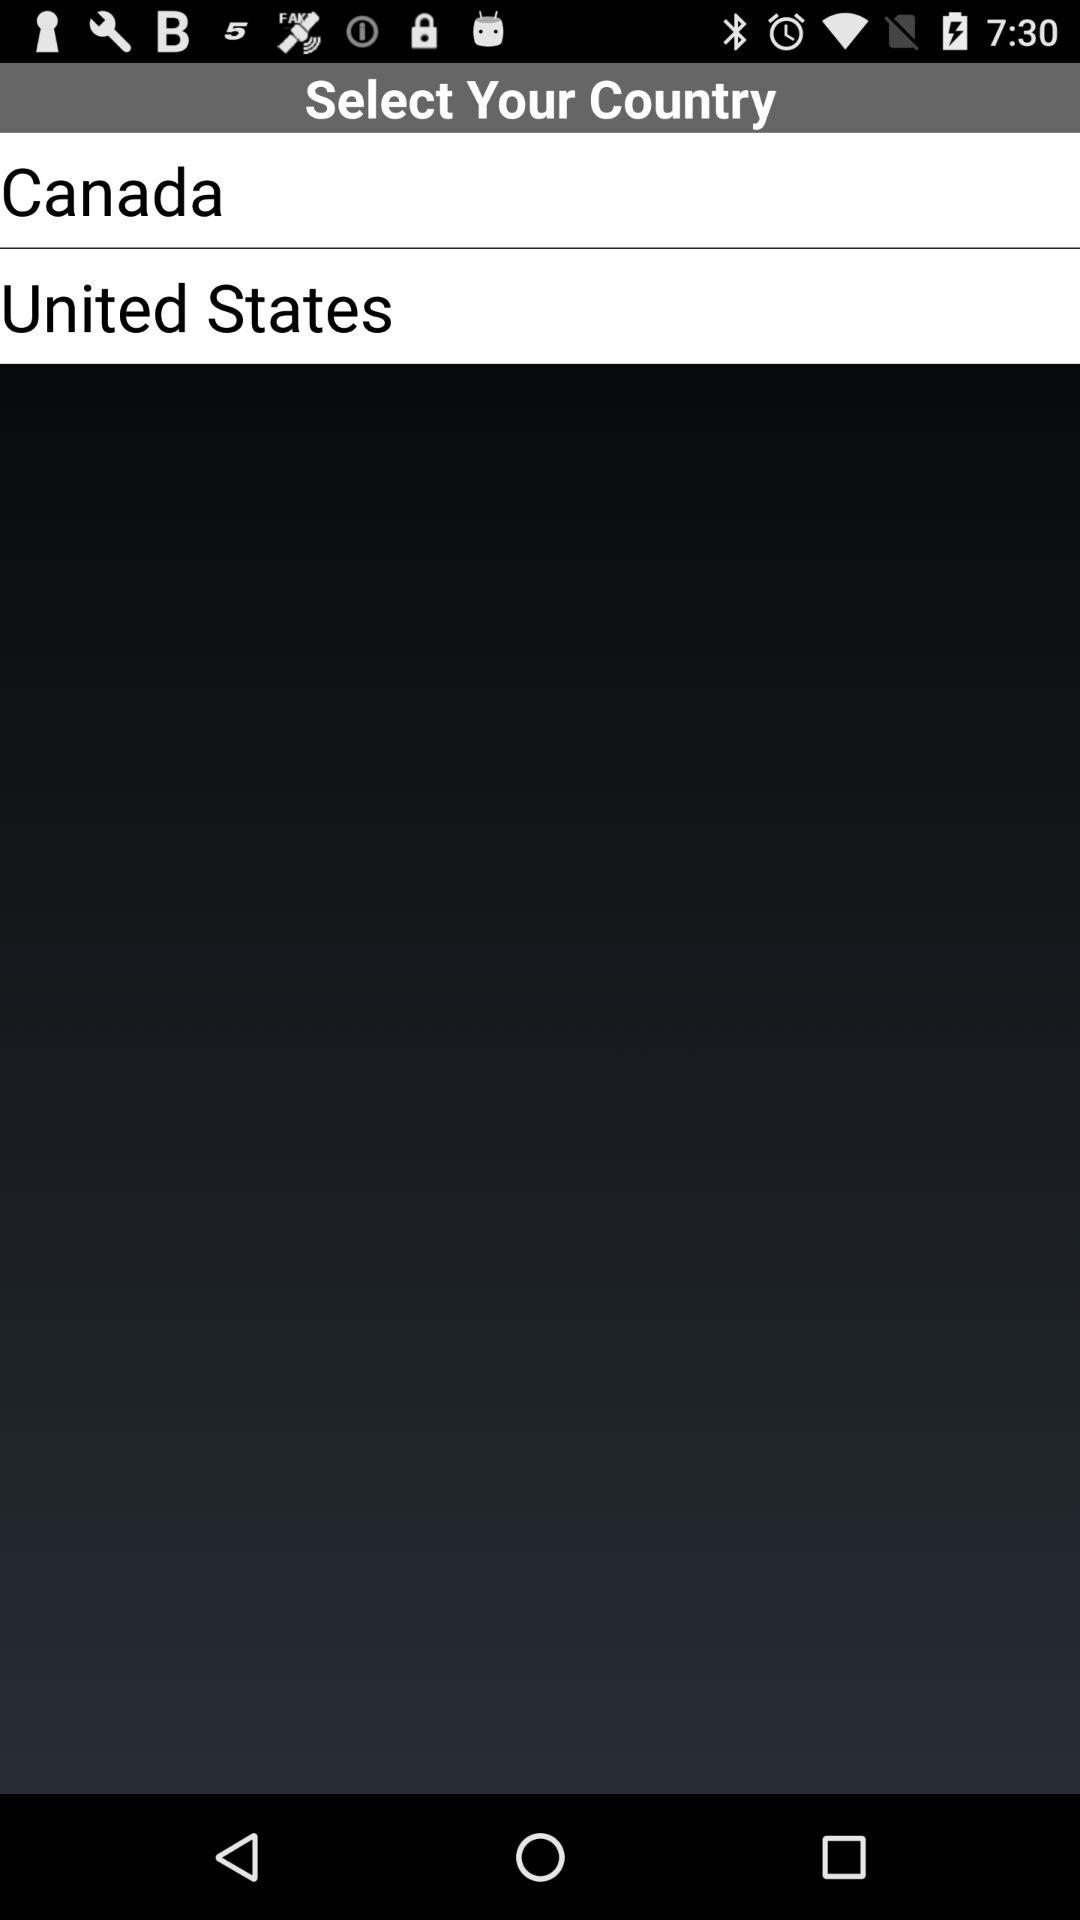Which two countries are given for the selection? The two countries are Canada and the United States. 